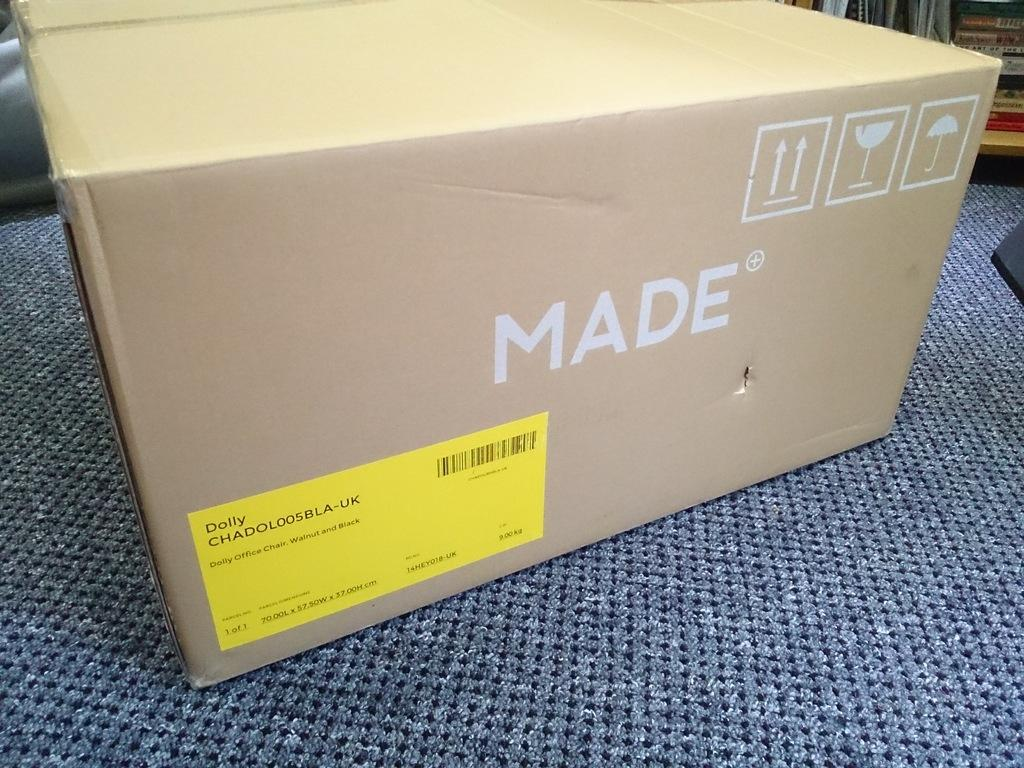Provide a one-sentence caption for the provided image. A beige box that is by a brand called Made. 